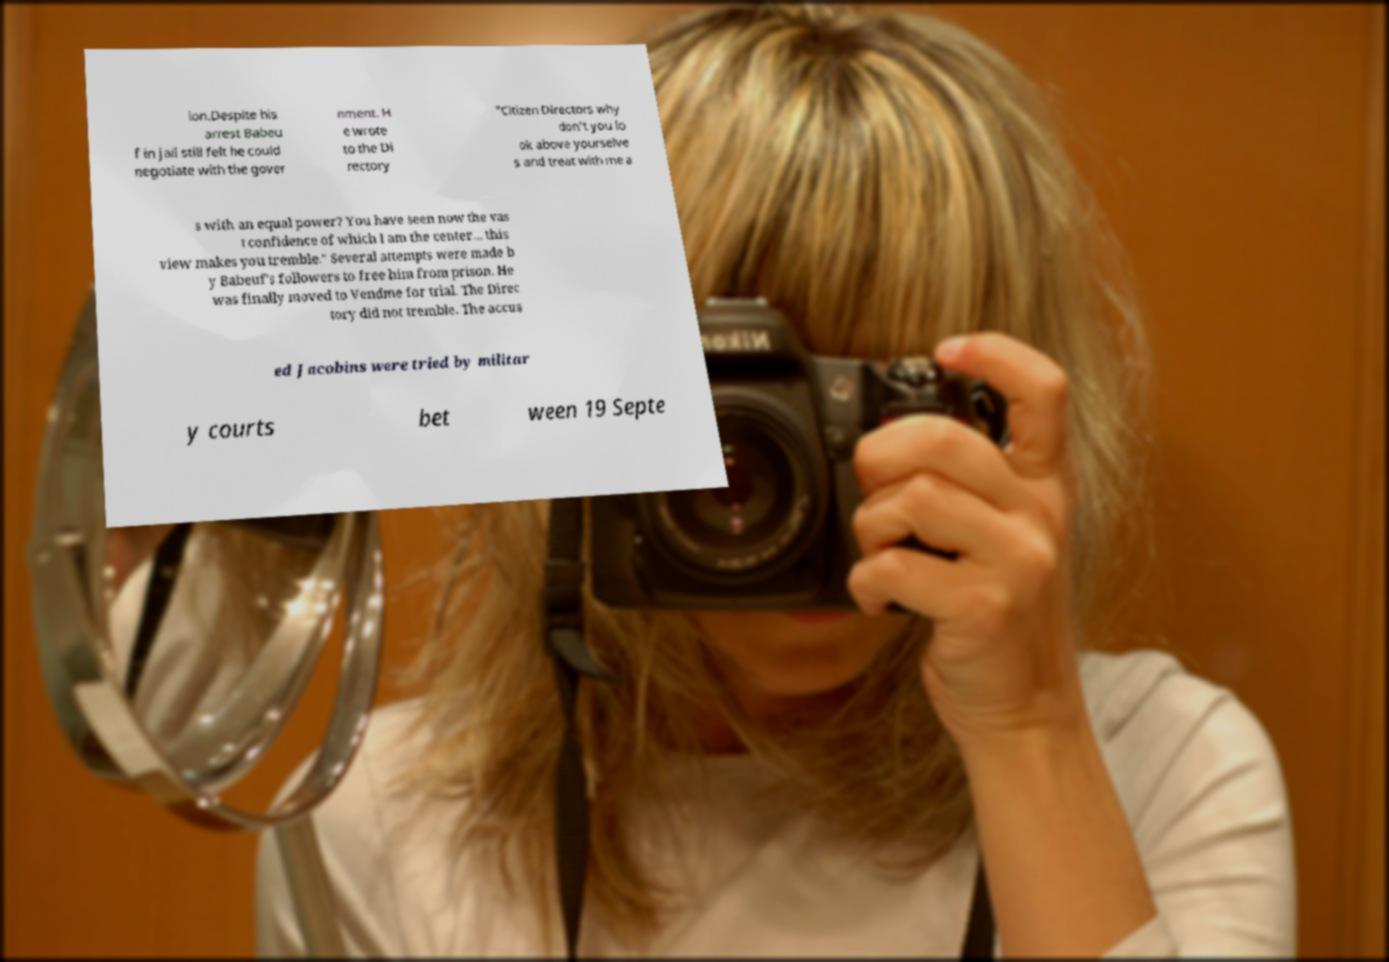I need the written content from this picture converted into text. Can you do that? ion.Despite his arrest Babeu f in jail still felt he could negotiate with the gover nment. H e wrote to the Di rectory "Citizen Directors why don't you lo ok above yourselve s and treat with me a s with an equal power? You have seen now the vas t confidence of which I am the center... this view makes you tremble." Several attempts were made b y Babeuf's followers to free him from prison. He was finally moved to Vendme for trial. The Direc tory did not tremble. The accus ed Jacobins were tried by militar y courts bet ween 19 Septe 